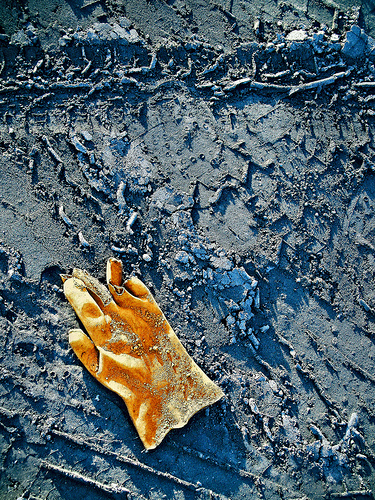<image>
Can you confirm if the glove is under the stick? No. The glove is not positioned under the stick. The vertical relationship between these objects is different. 